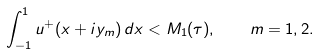Convert formula to latex. <formula><loc_0><loc_0><loc_500><loc_500>\int _ { - 1 } ^ { 1 } u ^ { + } ( x + i y _ { m } ) \, d x < M _ { 1 } ( \tau ) , \quad m = 1 , 2 .</formula> 